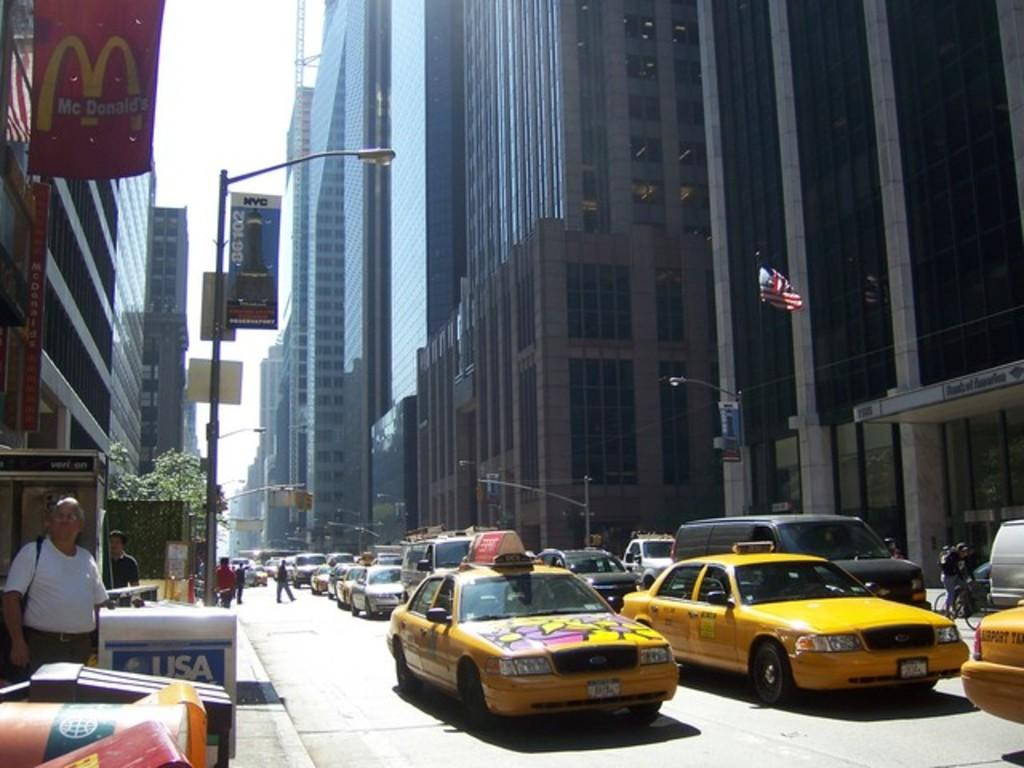Provide a one-sentence caption for the provided image. USA Today newspaper boxes are available on busy city streets. 